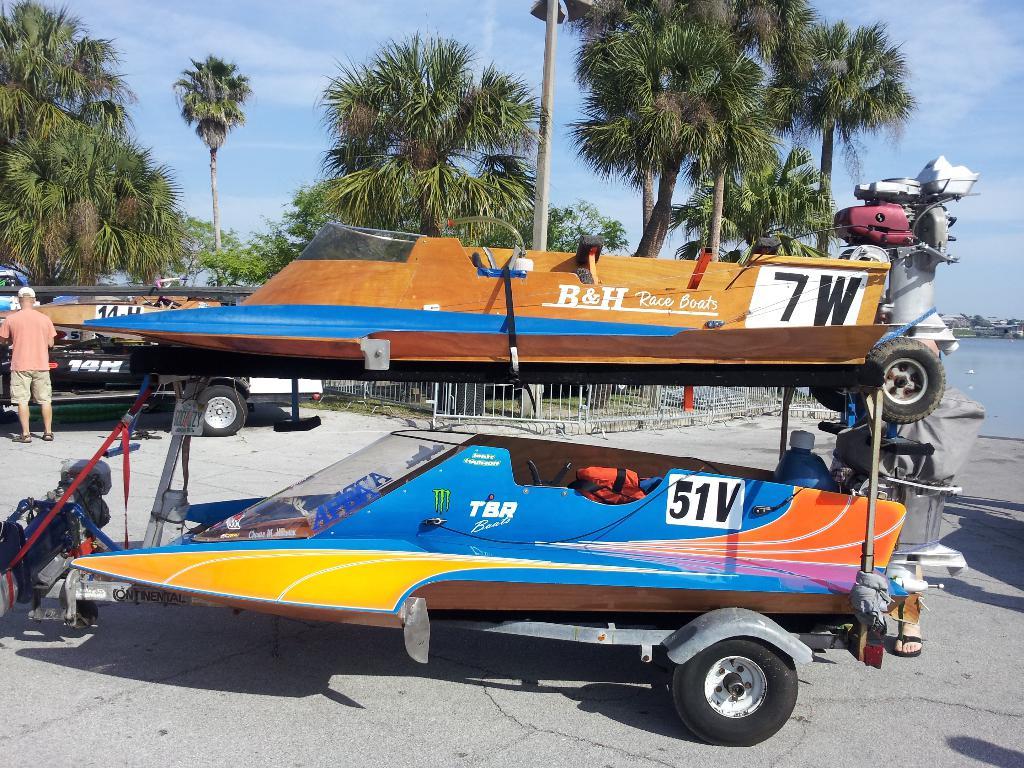What does it say on the top boat say?
Your response must be concise. B&h race boats. What number is on the second boat?
Make the answer very short. 51. 